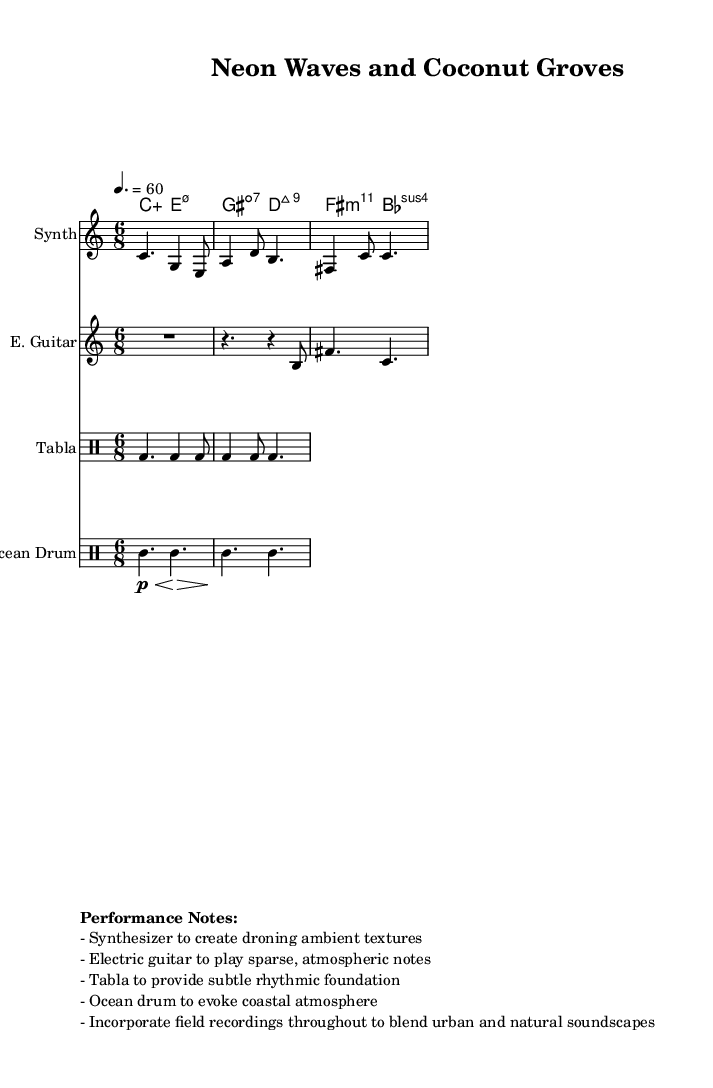What is the time signature of this music? The time signature is found at the beginning of the global section, which indicates there are six eighth notes per measure. This is represented as "6/8".
Answer: 6/8 What is the tempo marking of this piece? The tempo marking is indicated in the global section, shown as "4. = 60". This means a quarter note is to be played at a speed of 60 beats per minute.
Answer: 60 How many different instruments are used in this composition? The composition features four instruments: a synthesizer, an electric guitar, a tabla, and an ocean drum. Each is written in separate staffs.
Answer: Four What type of chord is the first one in the chord names? The first chord is indicated by the notation "c:aug" which denotes that it is an augmented chord built on the note C.
Answer: Augmented What rhythm is primarily used in the tabla part? The tabla part shows a repeating rhythmic pattern throughout the measure, primarily based on a combination of bass and additional strokes, which we see written in a rhythmic notation format.
Answer: Bass and additional strokes What performance element is suggested for incorporating ambient textures? The performance notes suggest using the synthesizer to create droning ambient textures, highlighting the atmospheric nature of the piece.
Answer: Droning ambient textures What is the purpose of the ocean drum in this piece? The performance notes indicate that the ocean drum's purpose is to evoke a coastal atmosphere, contributing to the overall theme of the composition that connects urban and natural soundscapes.
Answer: Evoke coastal atmosphere 